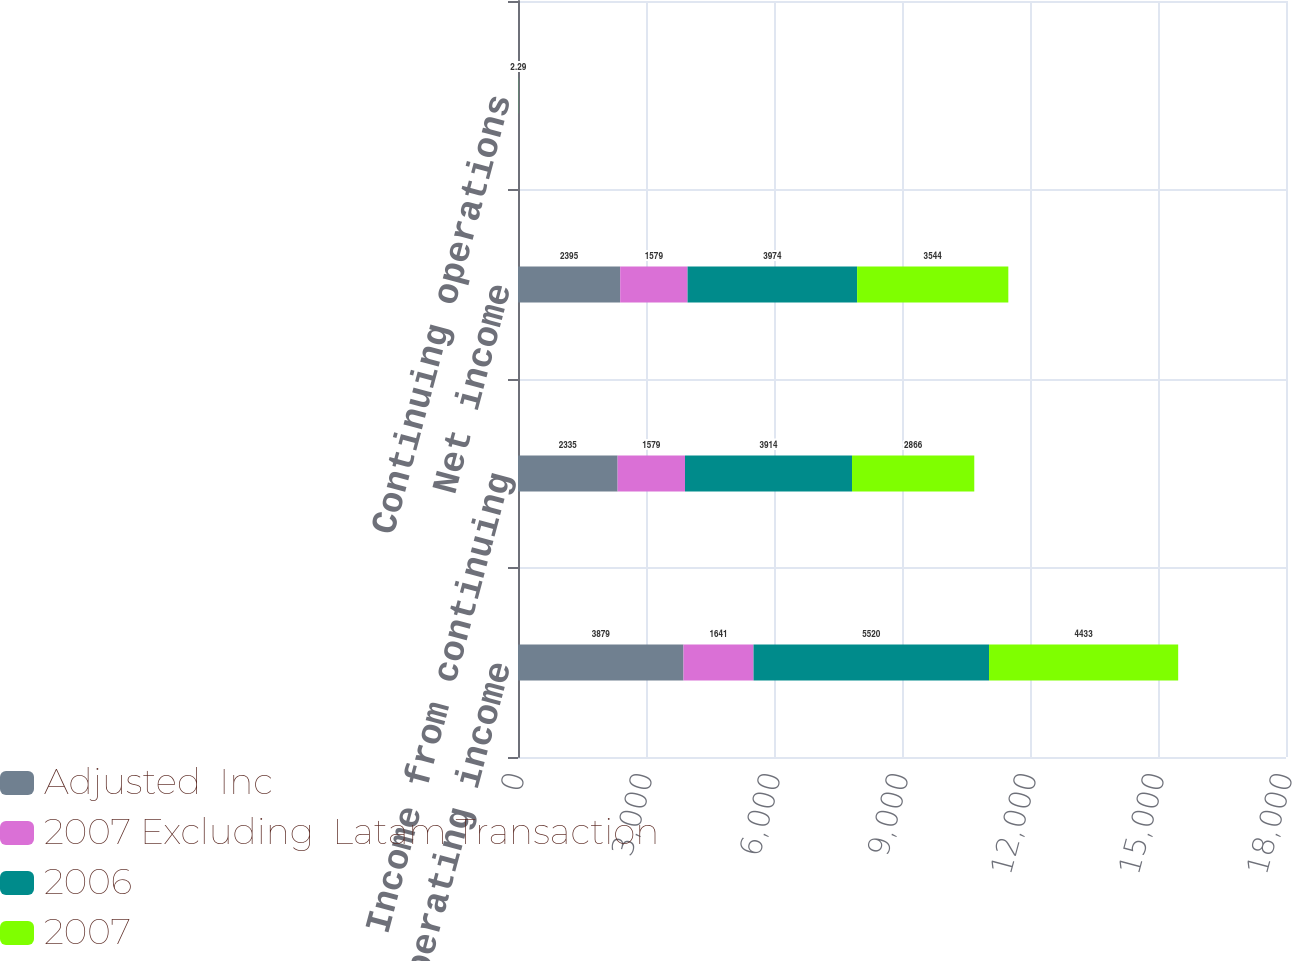<chart> <loc_0><loc_0><loc_500><loc_500><stacked_bar_chart><ecel><fcel>Operating income<fcel>Income from continuing<fcel>Net income<fcel>Continuing operations<nl><fcel>Adjusted  Inc<fcel>3879<fcel>2335<fcel>2395<fcel>1.93<nl><fcel>2007 Excluding  Latam Transaction<fcel>1641<fcel>1579<fcel>1579<fcel>1.3<nl><fcel>2006<fcel>5520<fcel>3914<fcel>3974<fcel>3.23<nl><fcel>2007<fcel>4433<fcel>2866<fcel>3544<fcel>2.29<nl></chart> 